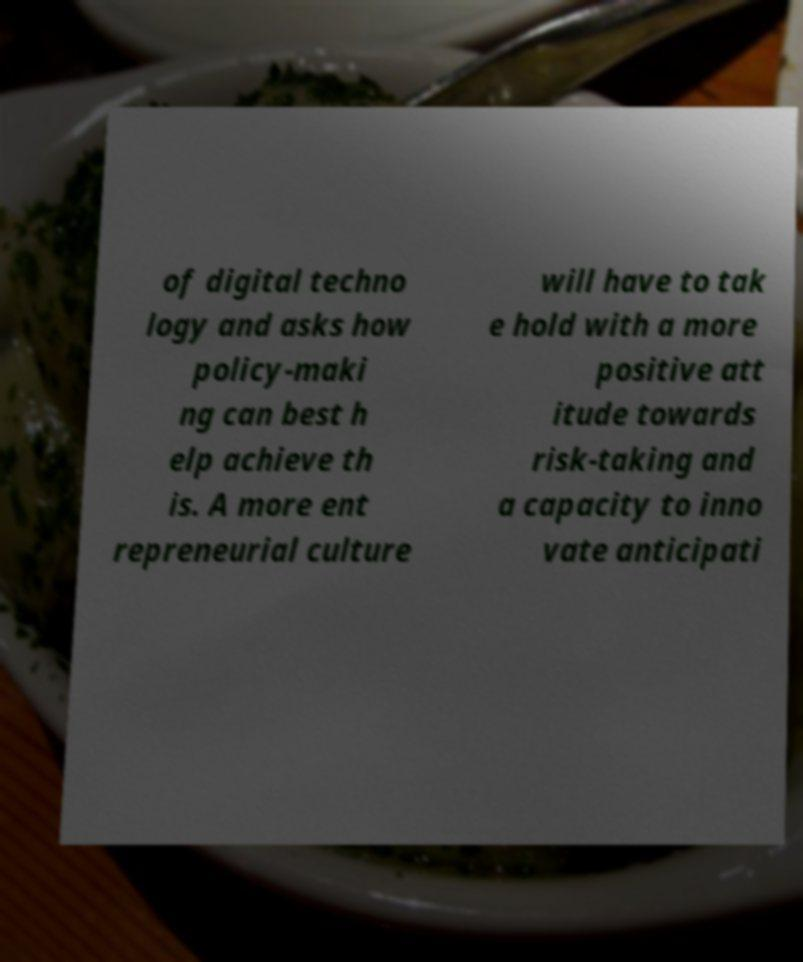There's text embedded in this image that I need extracted. Can you transcribe it verbatim? of digital techno logy and asks how policy-maki ng can best h elp achieve th is. A more ent repreneurial culture will have to tak e hold with a more positive att itude towards risk-taking and a capacity to inno vate anticipati 